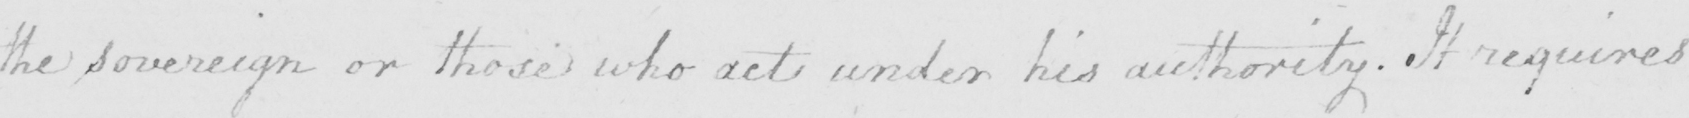Transcribe the text shown in this historical manuscript line. the Sovereign or those who act under his authority . It requires 